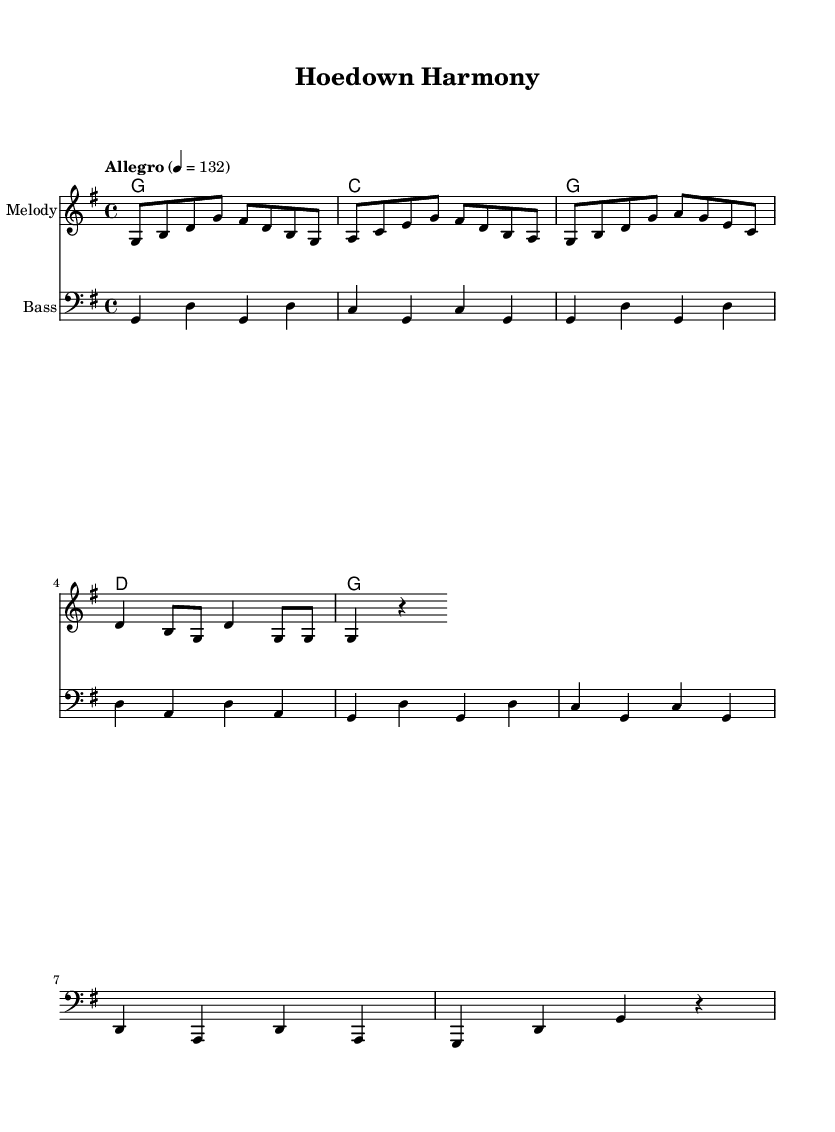What is the key signature of this music? The key signature indicates G major, which has one sharp (F#). This can be identified on the left side of the sheet music, where the key signature is displayed.
Answer: G major What is the time signature of this music? The time signature is 4/4, which is shown at the beginning of the score. This means there are four beats in a measure, and a quarter note gets one beat.
Answer: 4/4 What is the tempo marking of this piece? The tempo marking indicates the speed of the music, which is marked as "Allegro" with a metronome marking of 132. This informs the performers to play at a lively pace.
Answer: Allegro 4 = 132 What is the first note of the melody? The first note of the melody is G, which is indicated as the starting note in the melody staff. This can be observed at the beginning of the melodic line in the score.
Answer: G How many measures are there in the melody? By counting the groupings of notes plus rests in the melody, we can see there are 8 measures in total. Each measure contains a specific number of notes grouped together.
Answer: 8 What chords are used in the harmonies section? The chords listed in the harmonies section include G, C, and D. These chords are the foundational elements supporting the melody and can be seen in the chord names under the score.
Answer: G, C, D What is the last note in the bass line? The last note in the bass line is G, which can be located at the end of the bass staff, indicating the final pitch of the piece.
Answer: G 